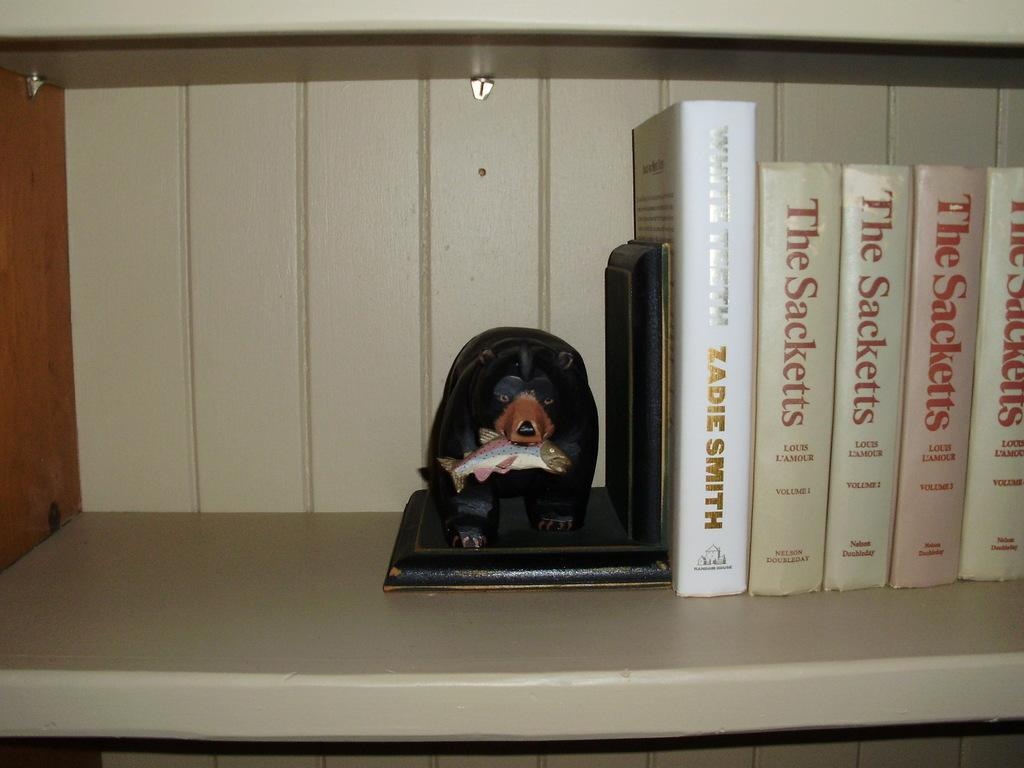What type of objects can be seen on the shelf in the image? There are books in the shelf in the image. What kind of sculpture is present in the image? There is a sculpture of a bear holding a fish in the image. What account does the bear have with the fish in the image? There is no account mentioned in the image; it features a sculpture of a bear holding a fish. How many degrees can be seen in the image? There are no degrees visible in the image; it features a sculpture of a bear holding a fish and books on a shelf. 